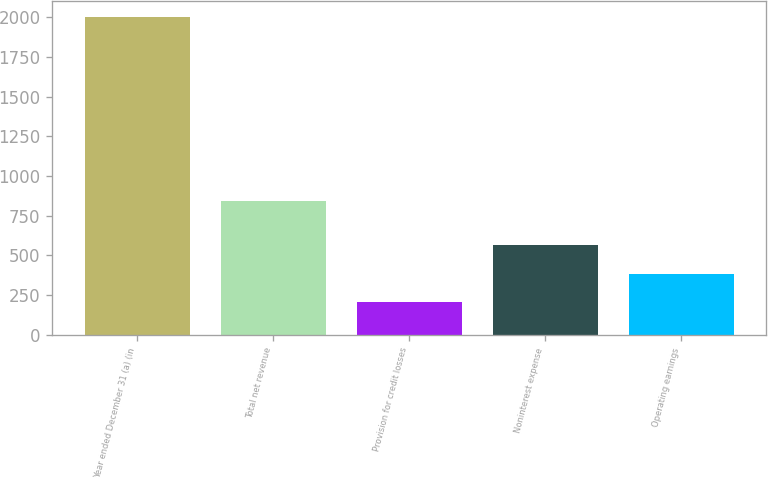Convert chart. <chart><loc_0><loc_0><loc_500><loc_500><bar_chart><fcel>Year ended December 31 (a) (in<fcel>Total net revenue<fcel>Provision for credit losses<fcel>Noninterest expense<fcel>Operating earnings<nl><fcel>2003<fcel>842<fcel>205<fcel>564.6<fcel>384.8<nl></chart> 